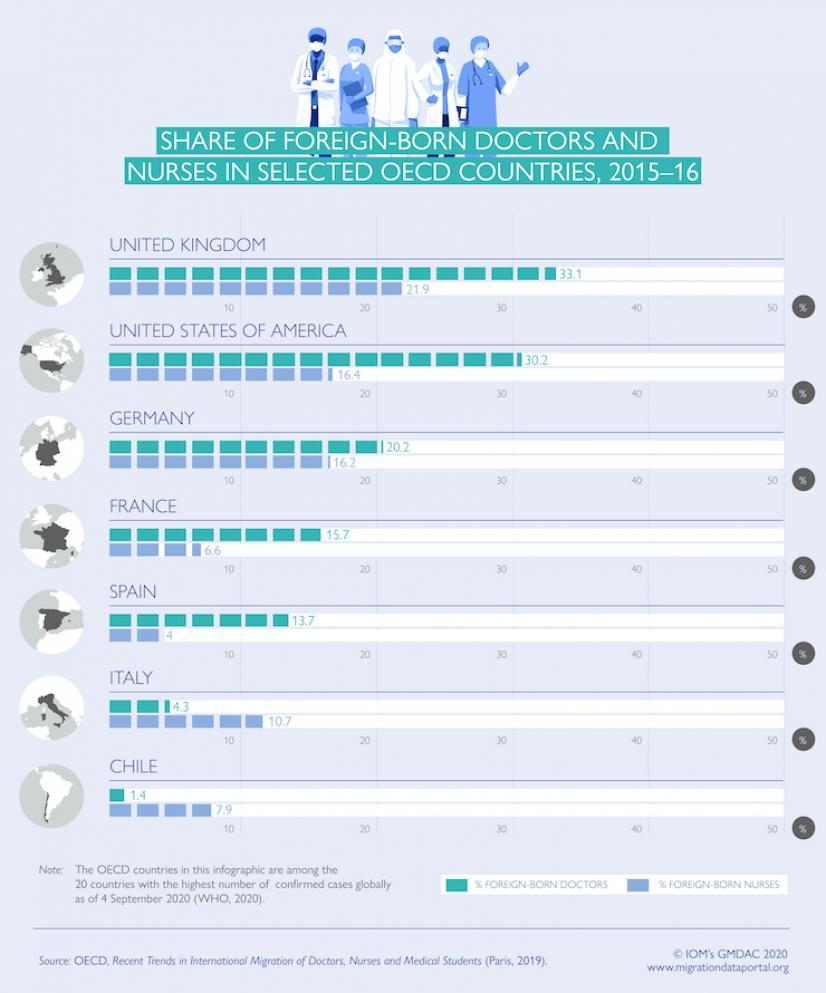What is the share of doctors in the UK and the USA, taken together?
Answer the question with a short phrase. 63.3 What is the share of doctors in Germany and France, taken together? 35.9 What is the share of nurses in Spain and Italy, taken together? 14.7 